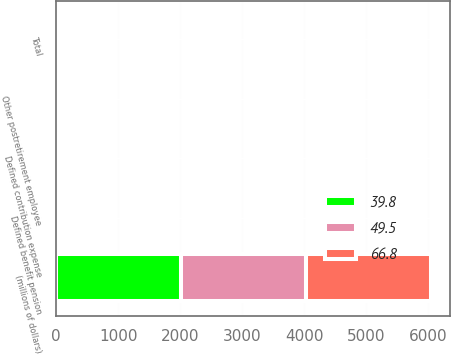<chart> <loc_0><loc_0><loc_500><loc_500><stacked_bar_chart><ecel><fcel>(millions of dollars)<fcel>Defined contribution expense<fcel>Defined benefit pension<fcel>Other postretirement employee<fcel>Total<nl><fcel>66.8<fcel>2016<fcel>28.3<fcel>10.1<fcel>1.4<fcel>39.8<nl><fcel>49.5<fcel>2015<fcel>28<fcel>35.5<fcel>3.3<fcel>66.8<nl><fcel>39.8<fcel>2014<fcel>27.6<fcel>18.6<fcel>3.3<fcel>49.5<nl></chart> 